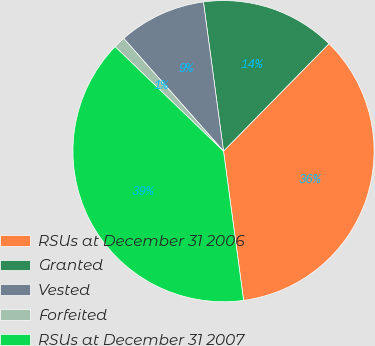Convert chart. <chart><loc_0><loc_0><loc_500><loc_500><pie_chart><fcel>RSUs at December 31 2006<fcel>Granted<fcel>Vested<fcel>Forfeited<fcel>RSUs at December 31 2007<nl><fcel>35.52%<fcel>14.48%<fcel>9.4%<fcel>1.26%<fcel>39.34%<nl></chart> 